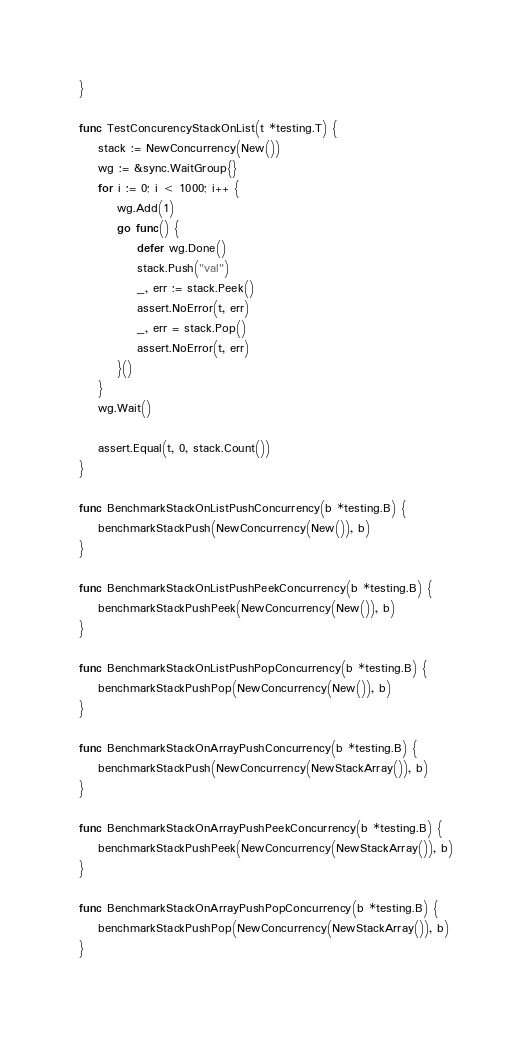<code> <loc_0><loc_0><loc_500><loc_500><_Go_>}

func TestConcurencyStackOnList(t *testing.T) {
	stack := NewConcurrency(New())
	wg := &sync.WaitGroup{}
	for i := 0; i < 1000; i++ {
		wg.Add(1)
		go func() {
			defer wg.Done()
			stack.Push("val")
			_, err := stack.Peek()
			assert.NoError(t, err)
			_, err = stack.Pop()
			assert.NoError(t, err)
		}()
	}
	wg.Wait()

	assert.Equal(t, 0, stack.Count())
}

func BenchmarkStackOnListPushConcurrency(b *testing.B) {
	benchmarkStackPush(NewConcurrency(New()), b)
}

func BenchmarkStackOnListPushPeekConcurrency(b *testing.B) {
	benchmarkStackPushPeek(NewConcurrency(New()), b)
}

func BenchmarkStackOnListPushPopConcurrency(b *testing.B) {
	benchmarkStackPushPop(NewConcurrency(New()), b)
}

func BenchmarkStackOnArrayPushConcurrency(b *testing.B) {
	benchmarkStackPush(NewConcurrency(NewStackArray()), b)
}

func BenchmarkStackOnArrayPushPeekConcurrency(b *testing.B) {
	benchmarkStackPushPeek(NewConcurrency(NewStackArray()), b)
}

func BenchmarkStackOnArrayPushPopConcurrency(b *testing.B) {
	benchmarkStackPushPop(NewConcurrency(NewStackArray()), b)
}
</code> 